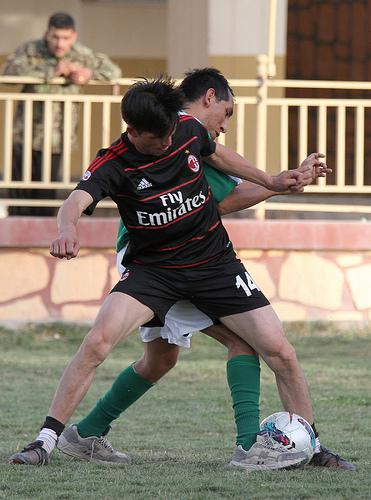Question: where was the picture taken?
Choices:
A. A football game.
B. A basketball game.
C. A hockey game.
D. On a soccer field.
Answer with the letter. Answer: D Question: when was the picture taken?
Choices:
A. Today.
B. Daytime.
C. Last week.
D. Sunday.
Answer with the letter. Answer: B Question: what color is the ball?
Choices:
A. Pink, green, yellow, and brown.
B. White, black, red, and blue.
C. Purple, teal, grey, and auburn.
D. Magenta, silver, gold, and indigo.
Answer with the letter. Answer: B Question: what type of ball is it?
Choices:
A. Football.
B. Baseball.
C. Soccer ball.
D. Golf ball.
Answer with the letter. Answer: C 